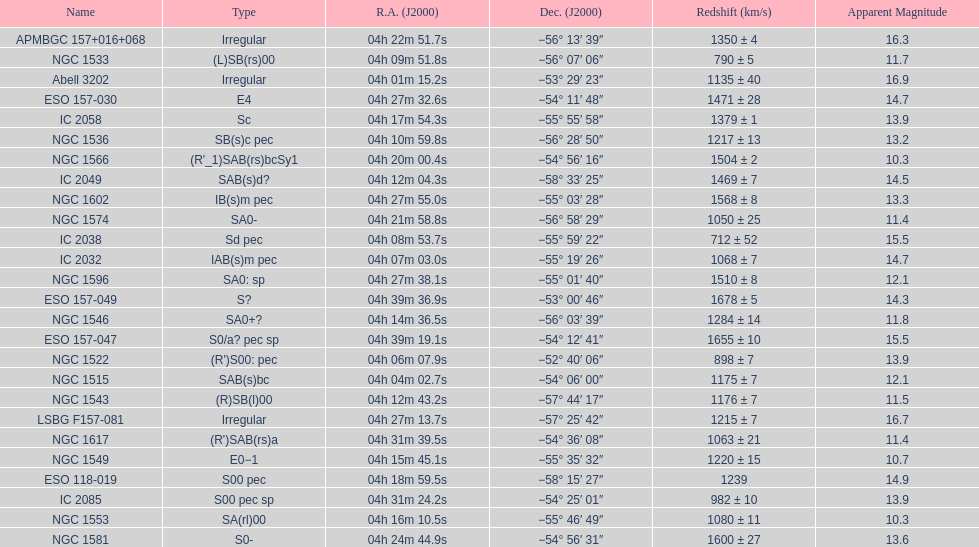What number of "irregular" types are there? 3. 